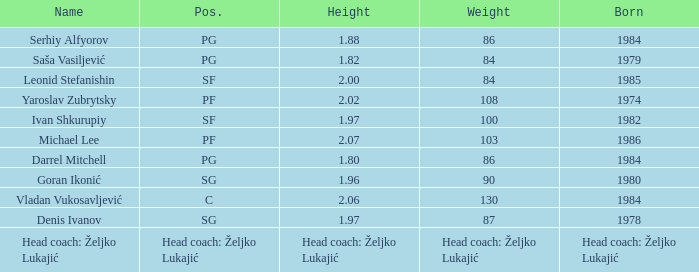80m? PG. 